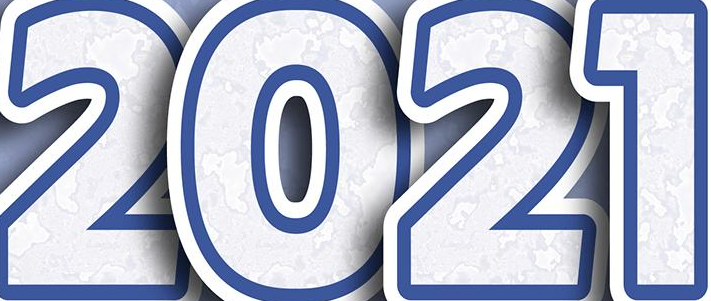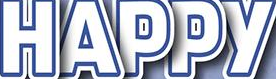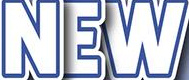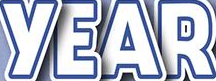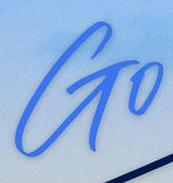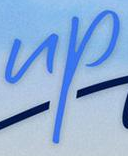What text appears in these images from left to right, separated by a semicolon? 2021; HAPPY; NEW; YEAR; Go; up 